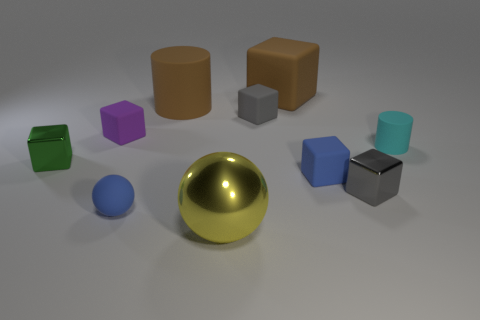Subtract all cyan cylinders. How many gray blocks are left? 2 Subtract all large cubes. How many cubes are left? 5 Subtract all gray blocks. How many blocks are left? 4 Subtract all green blocks. Subtract all yellow balls. How many blocks are left? 5 Subtract 0 yellow cylinders. How many objects are left? 10 Subtract all balls. How many objects are left? 8 Subtract all red rubber cylinders. Subtract all small cylinders. How many objects are left? 9 Add 6 big yellow spheres. How many big yellow spheres are left? 7 Add 5 red metal cubes. How many red metal cubes exist? 5 